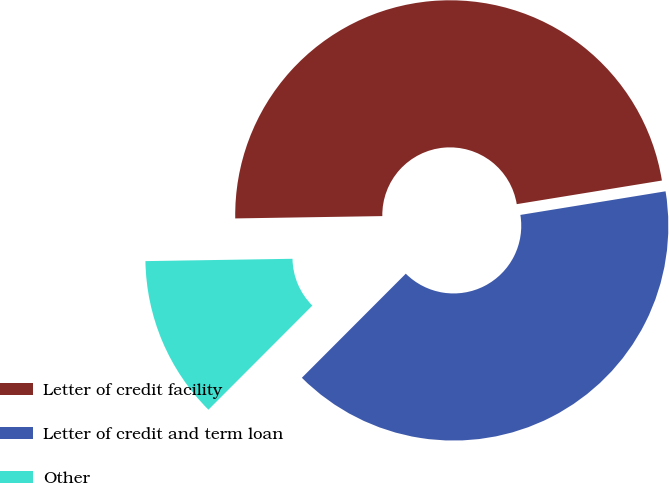<chart> <loc_0><loc_0><loc_500><loc_500><pie_chart><fcel>Letter of credit facility<fcel>Letter of credit and term loan<fcel>Other<nl><fcel>47.68%<fcel>40.05%<fcel>12.26%<nl></chart> 